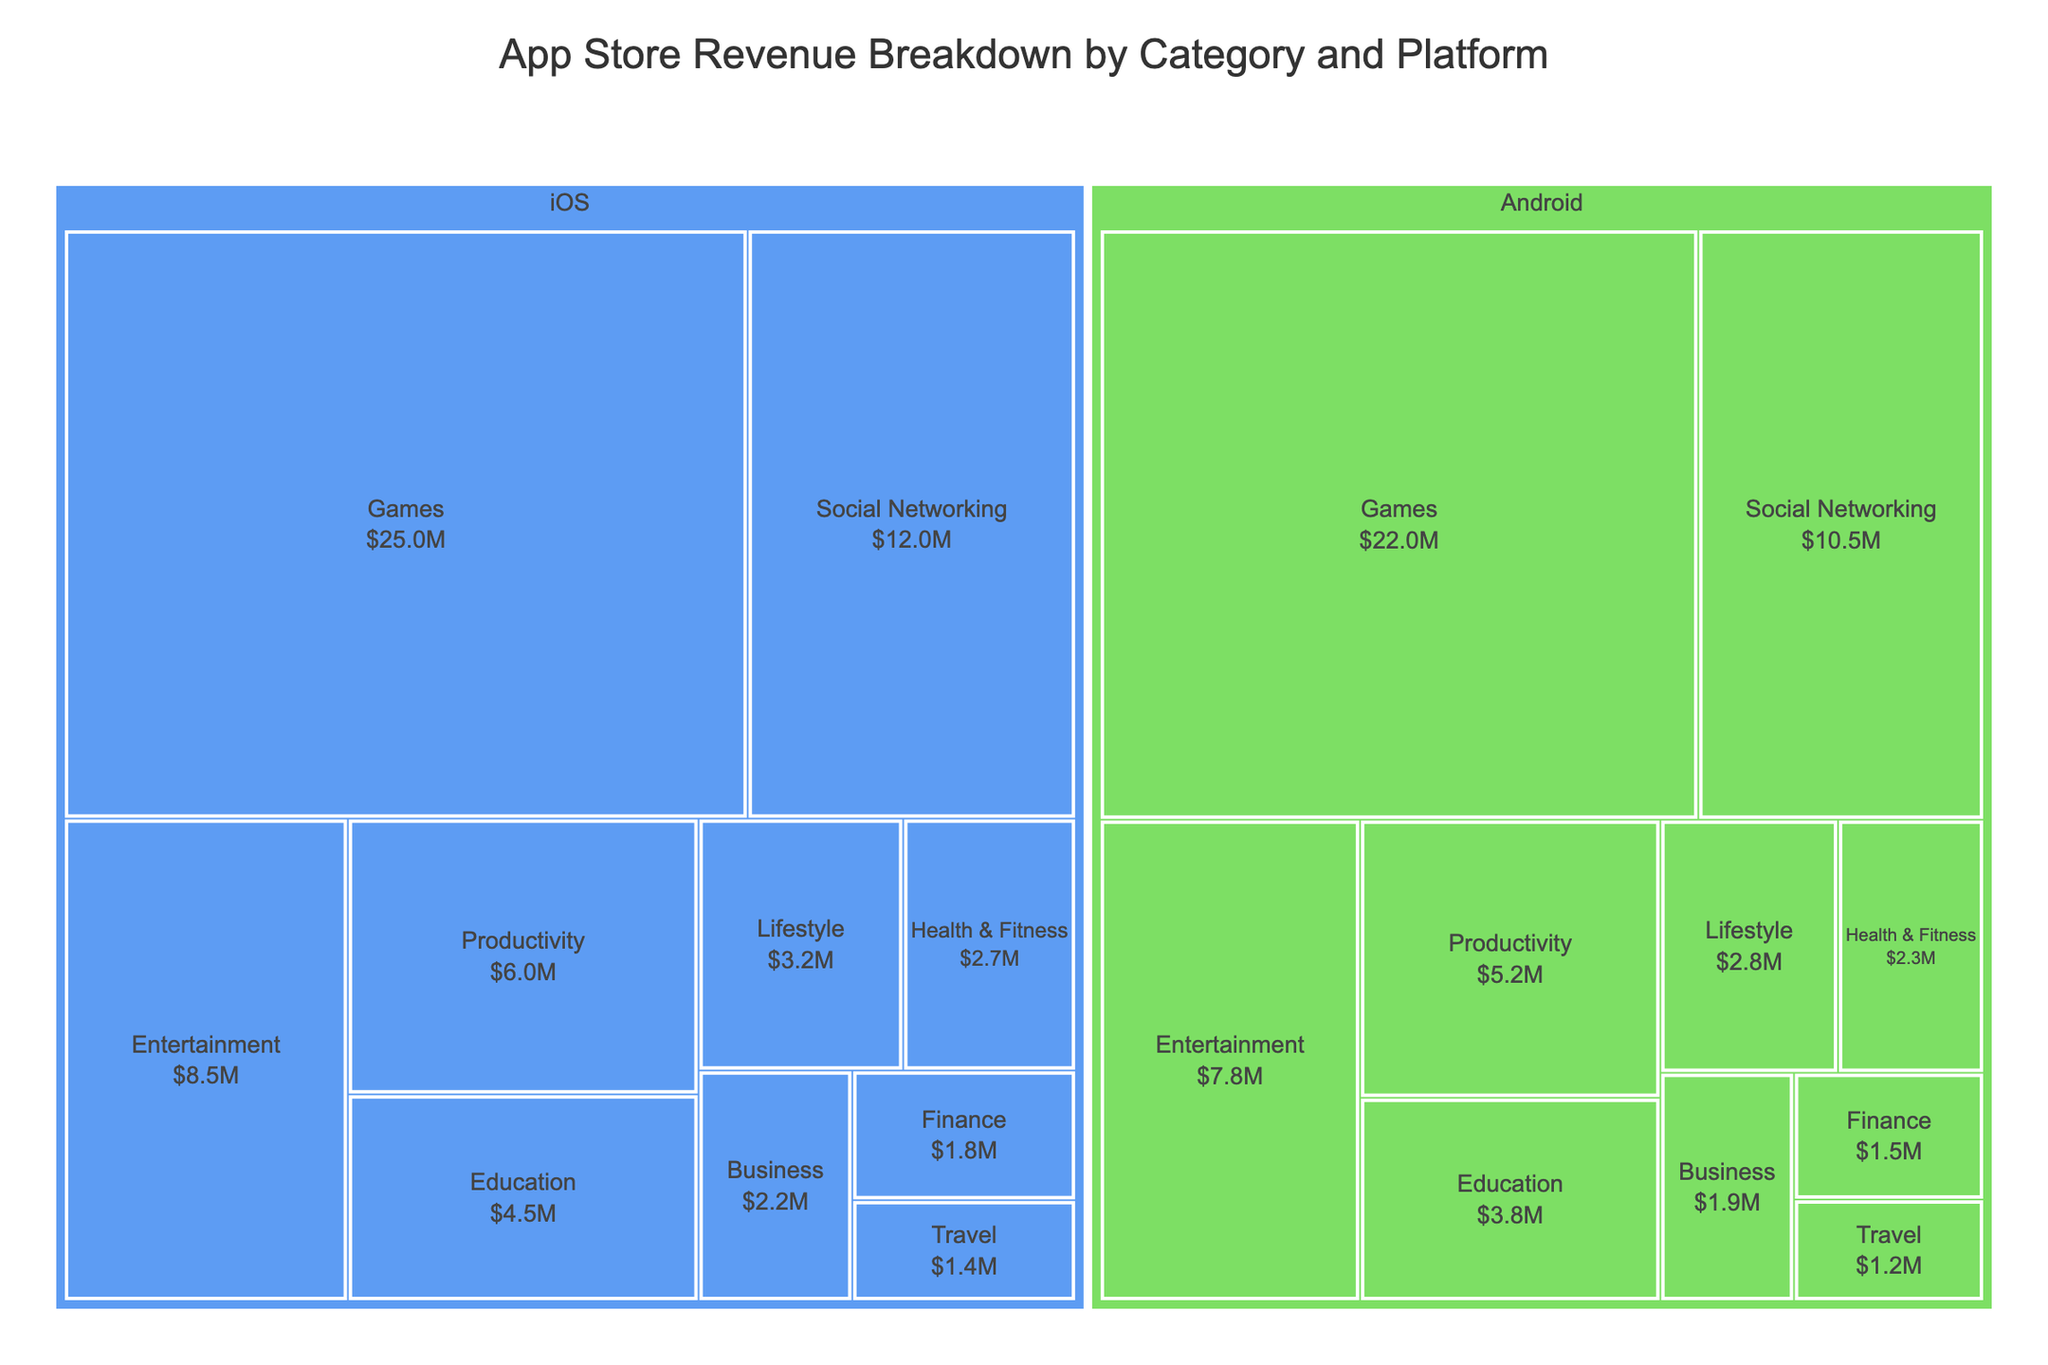Which platform generates the most revenue for the "Games" category? Look at the treemap for the "Games" category. Compare the sizes and revenue values for iOS and Android platforms in this category.
Answer: iOS What is the total revenue generated by the "Social Networking" category across both platforms? Find the revenue for "Social Networking" on both iOS and Android. Add them up: $12,000,000 (iOS) + $10,500,000 (Android).
Answer: $22,500,000 Which category has the smallest revenue on the Android platform? Observe the sizes and revenue values for each category on the Android platform. Identify the smallest one.
Answer: Travel How does the revenue of "Health & Fitness" on iOS compare to that on Android? Locate the "Health & Fitness" category for both iOS and Android. Compare their revenue values.
Answer: Higher on iOS For which category is the revenue almost equally split between iOS and Android? Look for categories where the revenue values for iOS and Android are nearly similar.
Answer: Entertainment What is the combined revenue from the "Productivity" and "Education" categories on the iOS platform? Find the revenue values for "Productivity" and "Education" on iOS. Add them together: $6,000,000 (Productivity) + $4,500,000 (Education).
Answer: $10,500,000 Compare the total revenue from all categories combined for iOS and Android. Which platform generates more revenue overall? Sum up the revenues for all categories on iOS and Android separately. Compare the two sums.
Answer: iOS Which category has the highest revenue on the iOS platform? Look at the treemap and identify the category with the largest revenue on iOS.
Answer: Games Is there a category where Android outperforms iOS in terms of revenue? If so, which one? Compare the revenues for each category across both platforms and see if Android has higher revenue in any category.
Answer: No What is the average revenue generated by the "Business" category on iOS and Android? Find the revenue values for "Business" on iOS and Android. Calculate the average: ($2,200,000 + $1,900,000) / 2.
Answer: $2,050,000 